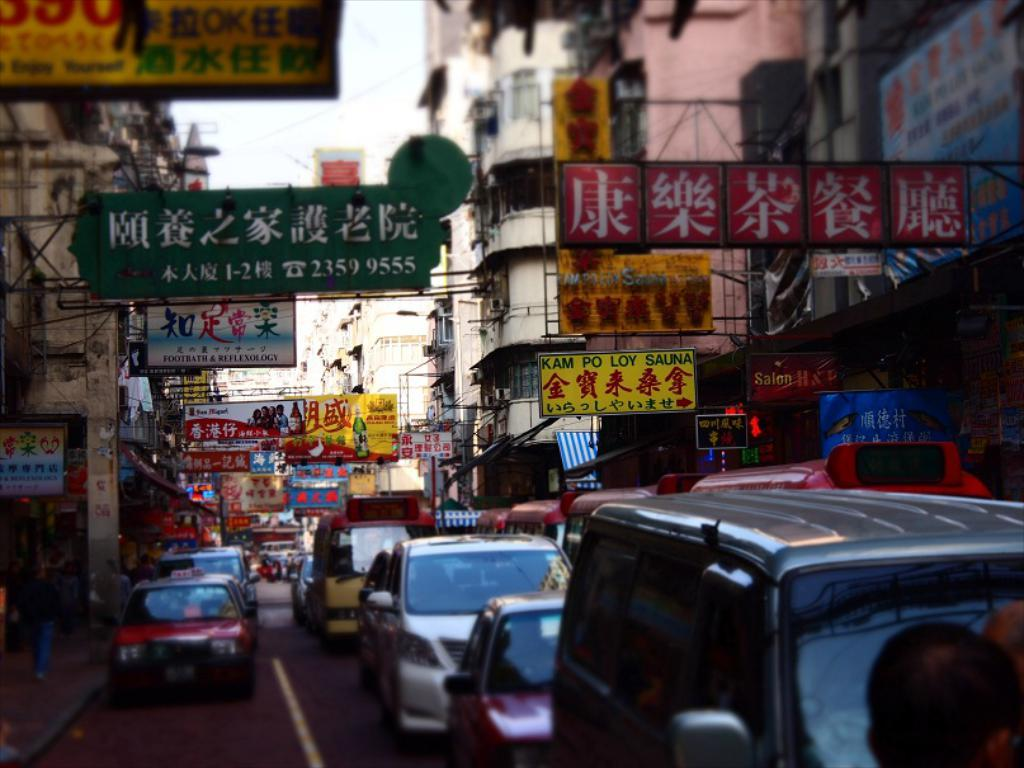Provide a one-sentence caption for the provided image. The yellow sign to the right advertises Kam Po Loy Sauna. 